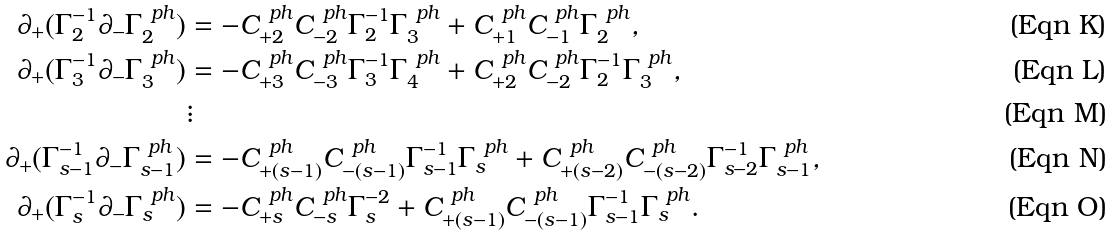Convert formula to latex. <formula><loc_0><loc_0><loc_500><loc_500>\partial _ { + } ( \Gamma _ { 2 } ^ { - 1 } \partial _ { - } \Gamma _ { 2 } ^ { \ p h } ) & = - C _ { + 2 } ^ { \ p h } C _ { - 2 } ^ { \ p h } \Gamma _ { 2 } ^ { - 1 } \Gamma _ { 3 } ^ { \ p h } + C _ { + 1 } ^ { \ p h } C _ { - 1 } ^ { \ p h } \Gamma _ { 2 } ^ { \ p h } , \\ \partial _ { + } ( \Gamma _ { 3 } ^ { - 1 } \partial _ { - } \Gamma _ { 3 } ^ { \ p h } ) & = - C _ { + 3 } ^ { \ p h } C _ { - 3 } ^ { \ p h } \Gamma _ { 3 } ^ { - 1 } \Gamma _ { 4 } ^ { \ p h } + C _ { + 2 } ^ { \ p h } C _ { - 2 } ^ { \ p h } \Gamma _ { 2 } ^ { - 1 } \Gamma _ { 3 } ^ { \ p h } , \\ & \vdots \\ \partial _ { + } ( \Gamma _ { s - 1 } ^ { - 1 } \partial _ { - } \Gamma _ { s - 1 } ^ { \ p h } ) & = - C _ { + ( s - 1 ) } ^ { \ p h } C _ { - ( s - 1 ) } ^ { \ p h } \Gamma _ { s - 1 } ^ { - 1 } \Gamma _ { s } ^ { \ p h } + C _ { + ( s - 2 ) } ^ { \ p h } C _ { - ( s - 2 ) } ^ { \ p h } \Gamma _ { s - 2 } ^ { - 1 } \Gamma _ { s - 1 } ^ { \ p h } , \\ \partial _ { + } ( \Gamma _ { s } ^ { - 1 } \partial _ { - } \Gamma _ { s } ^ { \ p h } ) & = - C _ { + s } ^ { \ p h } C _ { - s } ^ { \ p h } \Gamma _ { s } ^ { - 2 } + C _ { + ( s - 1 ) } ^ { \ p h } C _ { - ( s - 1 ) } ^ { \ p h } \Gamma _ { s - 1 } ^ { - 1 } \Gamma _ { s } ^ { \ p h } .</formula> 